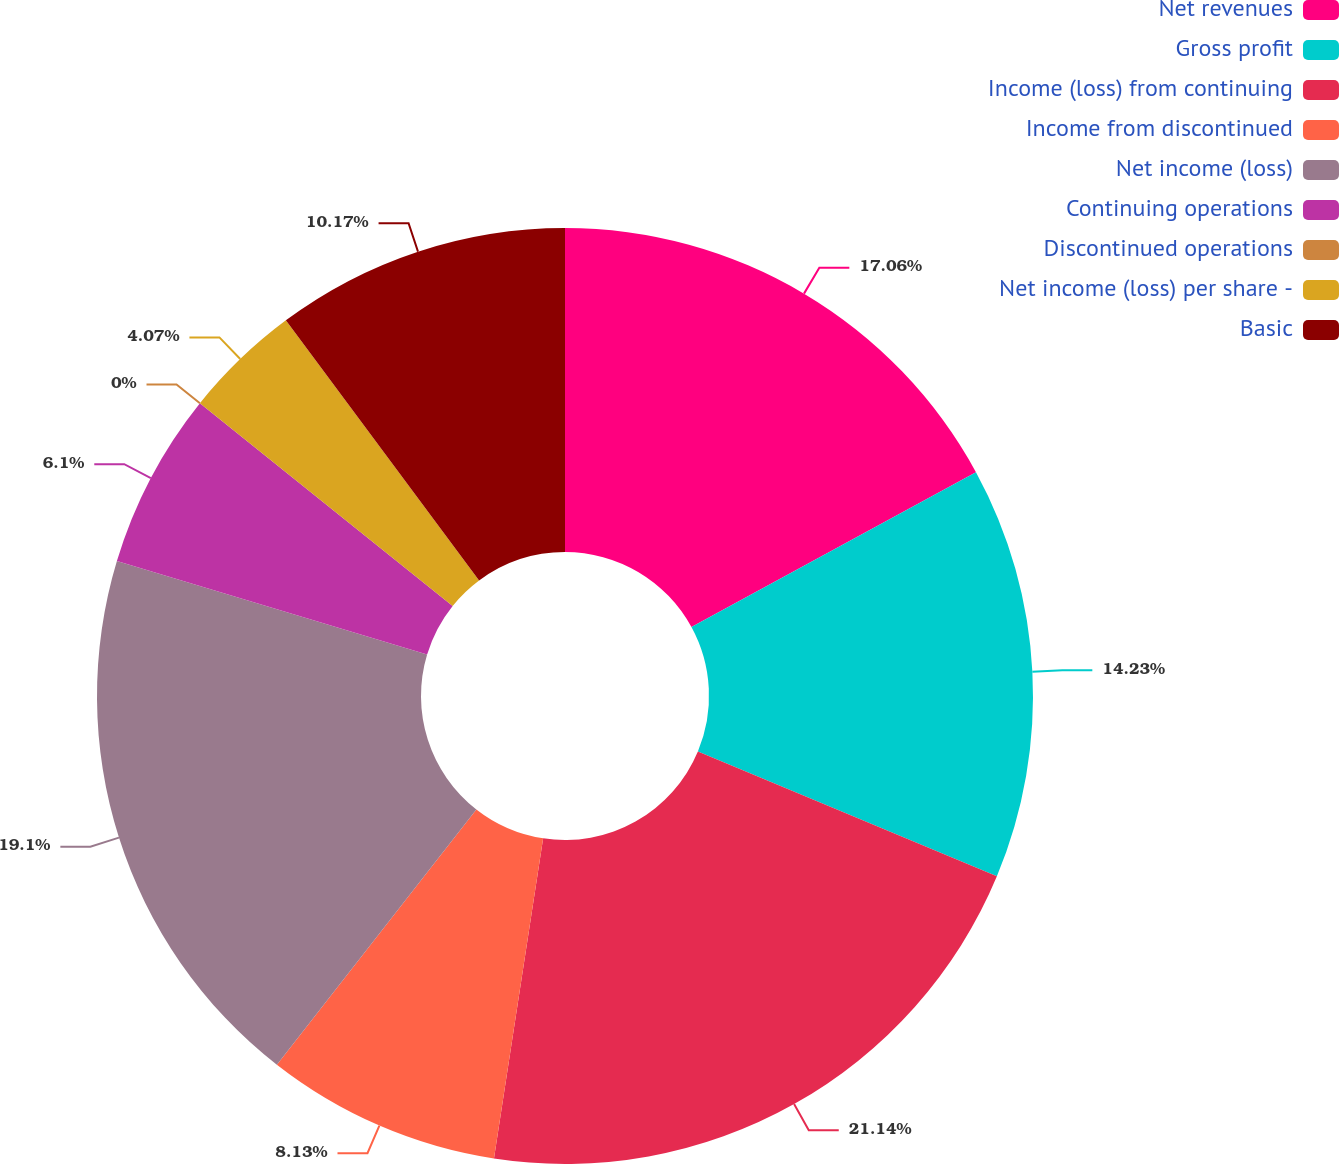<chart> <loc_0><loc_0><loc_500><loc_500><pie_chart><fcel>Net revenues<fcel>Gross profit<fcel>Income (loss) from continuing<fcel>Income from discontinued<fcel>Net income (loss)<fcel>Continuing operations<fcel>Discontinued operations<fcel>Net income (loss) per share -<fcel>Basic<nl><fcel>17.06%<fcel>14.23%<fcel>21.13%<fcel>8.13%<fcel>19.1%<fcel>6.1%<fcel>0.0%<fcel>4.07%<fcel>10.17%<nl></chart> 